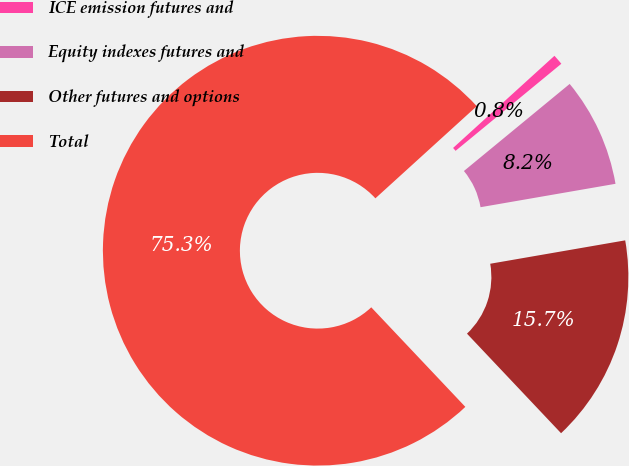Convert chart to OTSL. <chart><loc_0><loc_0><loc_500><loc_500><pie_chart><fcel>ICE emission futures and<fcel>Equity indexes futures and<fcel>Other futures and options<fcel>Total<nl><fcel>0.78%<fcel>8.23%<fcel>15.68%<fcel>75.3%<nl></chart> 